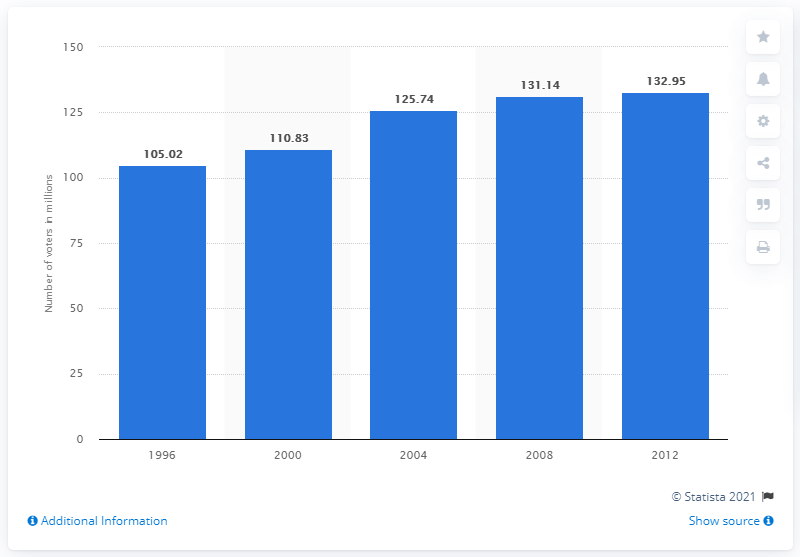Give some essential details in this illustration. In the presidential elections of 1996, a total of 105,021 people voted. 